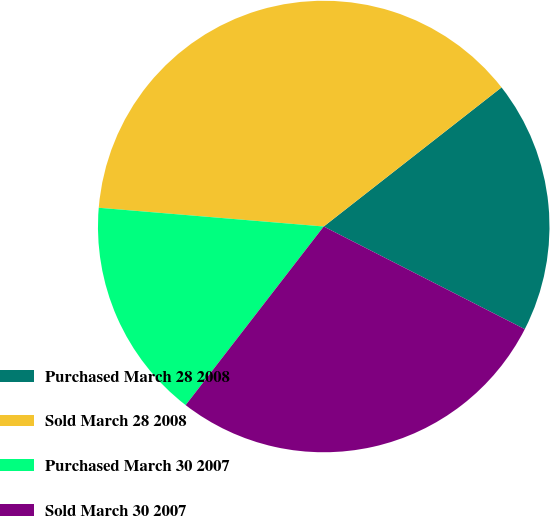Convert chart. <chart><loc_0><loc_0><loc_500><loc_500><pie_chart><fcel>Purchased March 28 2008<fcel>Sold March 28 2008<fcel>Purchased March 30 2007<fcel>Sold March 30 2007<nl><fcel>18.08%<fcel>38.11%<fcel>15.85%<fcel>27.96%<nl></chart> 